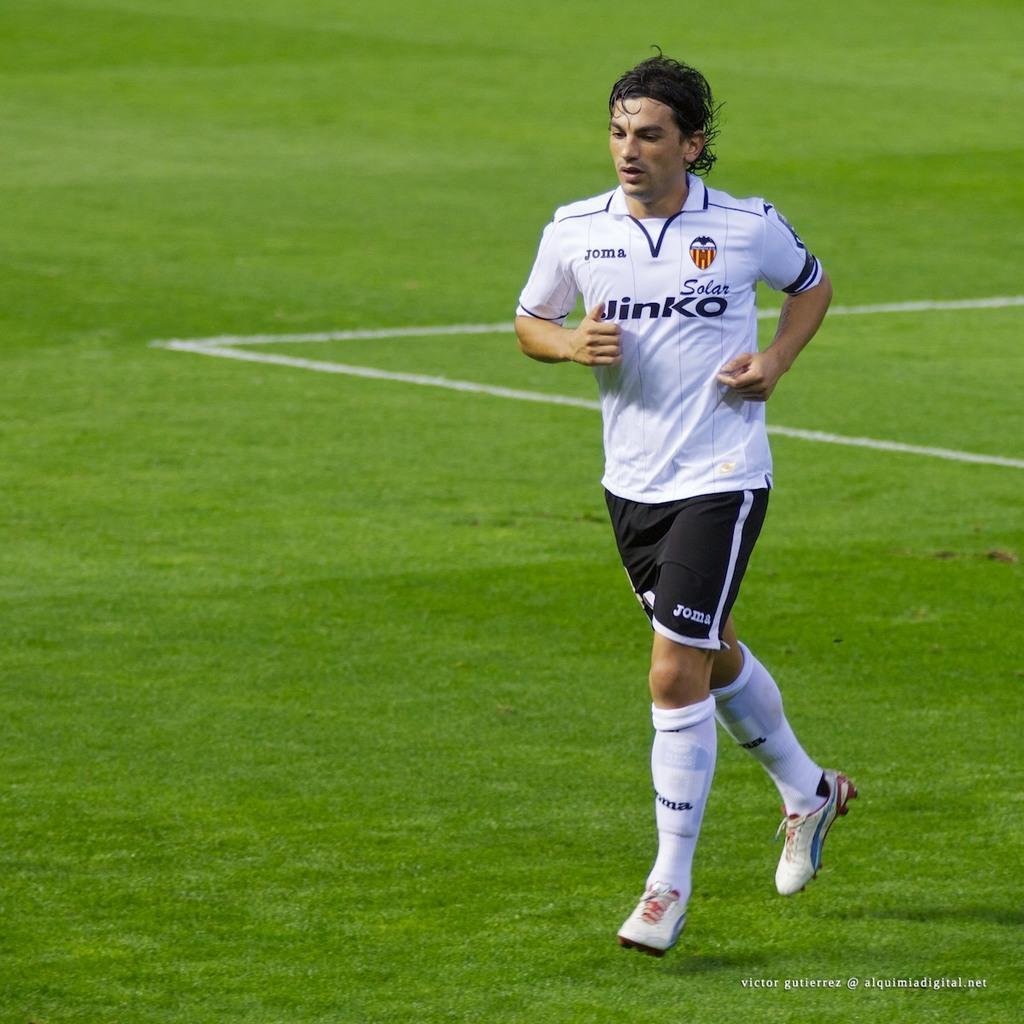Who is the main subject in the image? There is a man in the image. What is the man doing in the image? The man is running on the grass. What color is the man's t-shirt in the image? The man is wearing a white t-shirt. What color are the man's shorts in the image? The man is wearing black shorts. What color are the man's shoes in the image? The man is wearing white shoes. What date is circled on the calendar in the image? There is no calendar present in the image; it features a man running on the grass while wearing a white t-shirt, black shorts, and white shoes. 